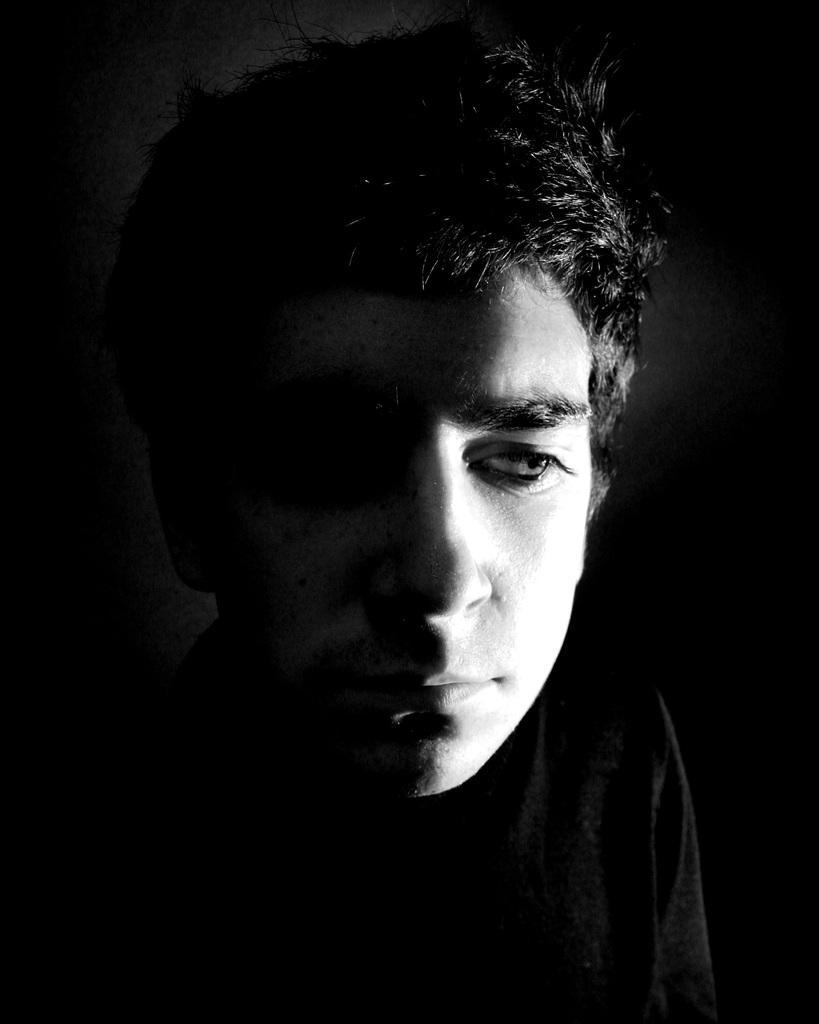What is the main subject of the image? There is a man in the image. What can be said about the color scheme of the image? The image is black and white in color. How many pies can be seen on the table in the image? There is no table or pies present in the image; it only features a man in a black and white setting. What type of zebra is visible in the image? There is no zebra present in the image; it only features a man in a black and white setting. 